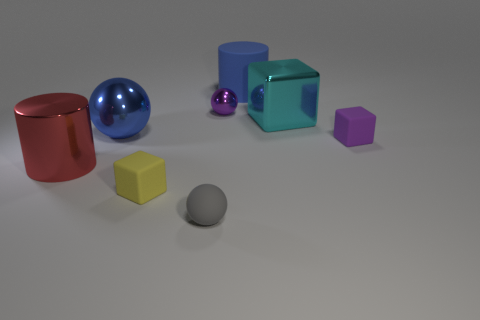Do the big shiny ball and the rubber cylinder have the same color?
Your response must be concise. Yes. There is a block that is the same color as the small metallic object; what is it made of?
Your answer should be very brief. Rubber. What number of cylinders have the same color as the big ball?
Provide a succinct answer. 1. There is a purple object right of the rubber cylinder; are there any large metal balls to the left of it?
Your answer should be very brief. Yes. How many other things are the same shape as the blue matte object?
Make the answer very short. 1. Do the gray matte thing and the purple metal object have the same shape?
Ensure brevity in your answer.  Yes. There is a metal thing that is both to the right of the red metallic thing and to the left of the tiny yellow thing; what color is it?
Give a very brief answer. Blue. There is a shiny thing that is the same color as the big matte cylinder; what is its size?
Keep it short and to the point. Large. How many small things are purple matte cubes or red metallic things?
Provide a succinct answer. 1. Are there any other things that have the same color as the small metal thing?
Offer a very short reply. Yes. 